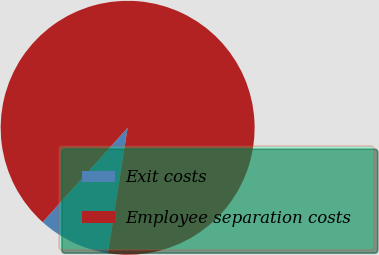<chart> <loc_0><loc_0><loc_500><loc_500><pie_chart><fcel>Exit costs<fcel>Employee separation costs<nl><fcel>9.18%<fcel>90.82%<nl></chart> 